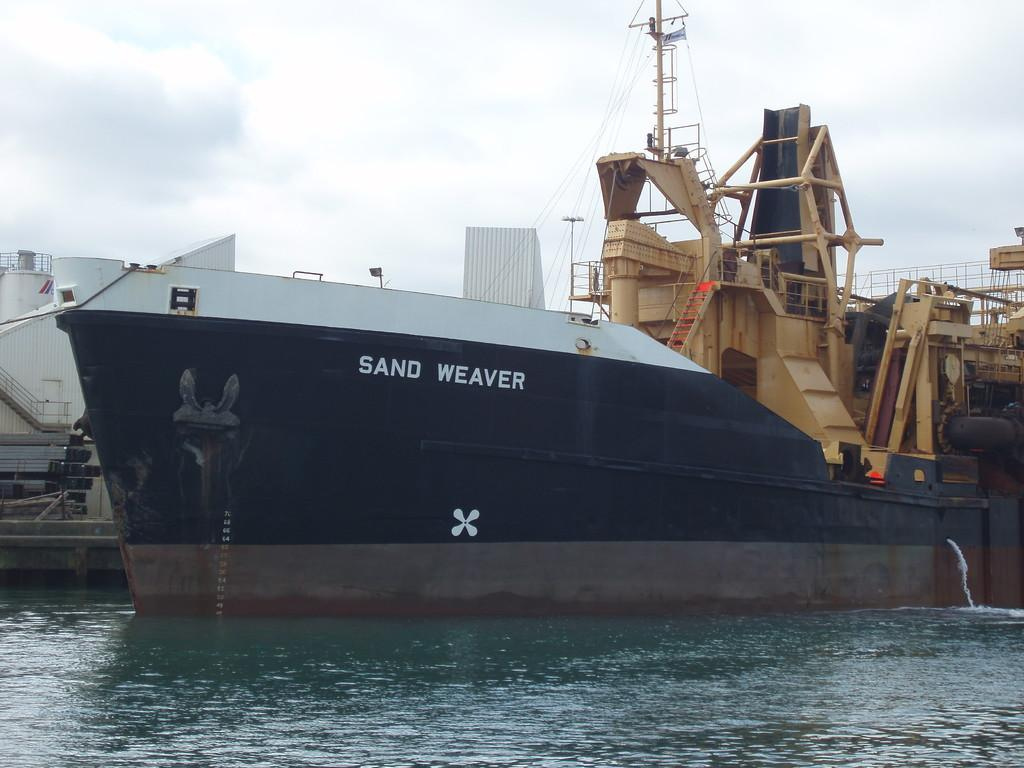<image>
Summarize the visual content of the image. Blue and white boat named SAND WEAVER in the waters. 